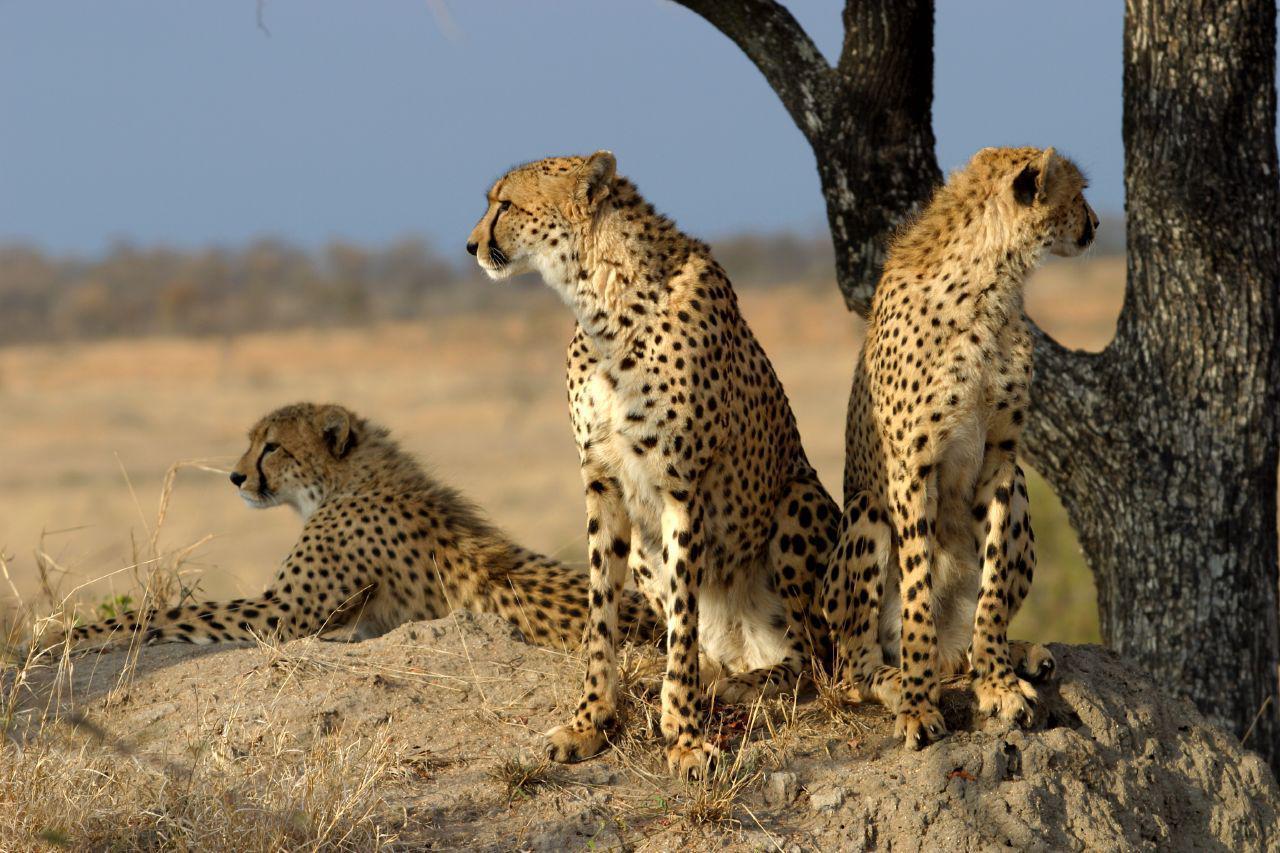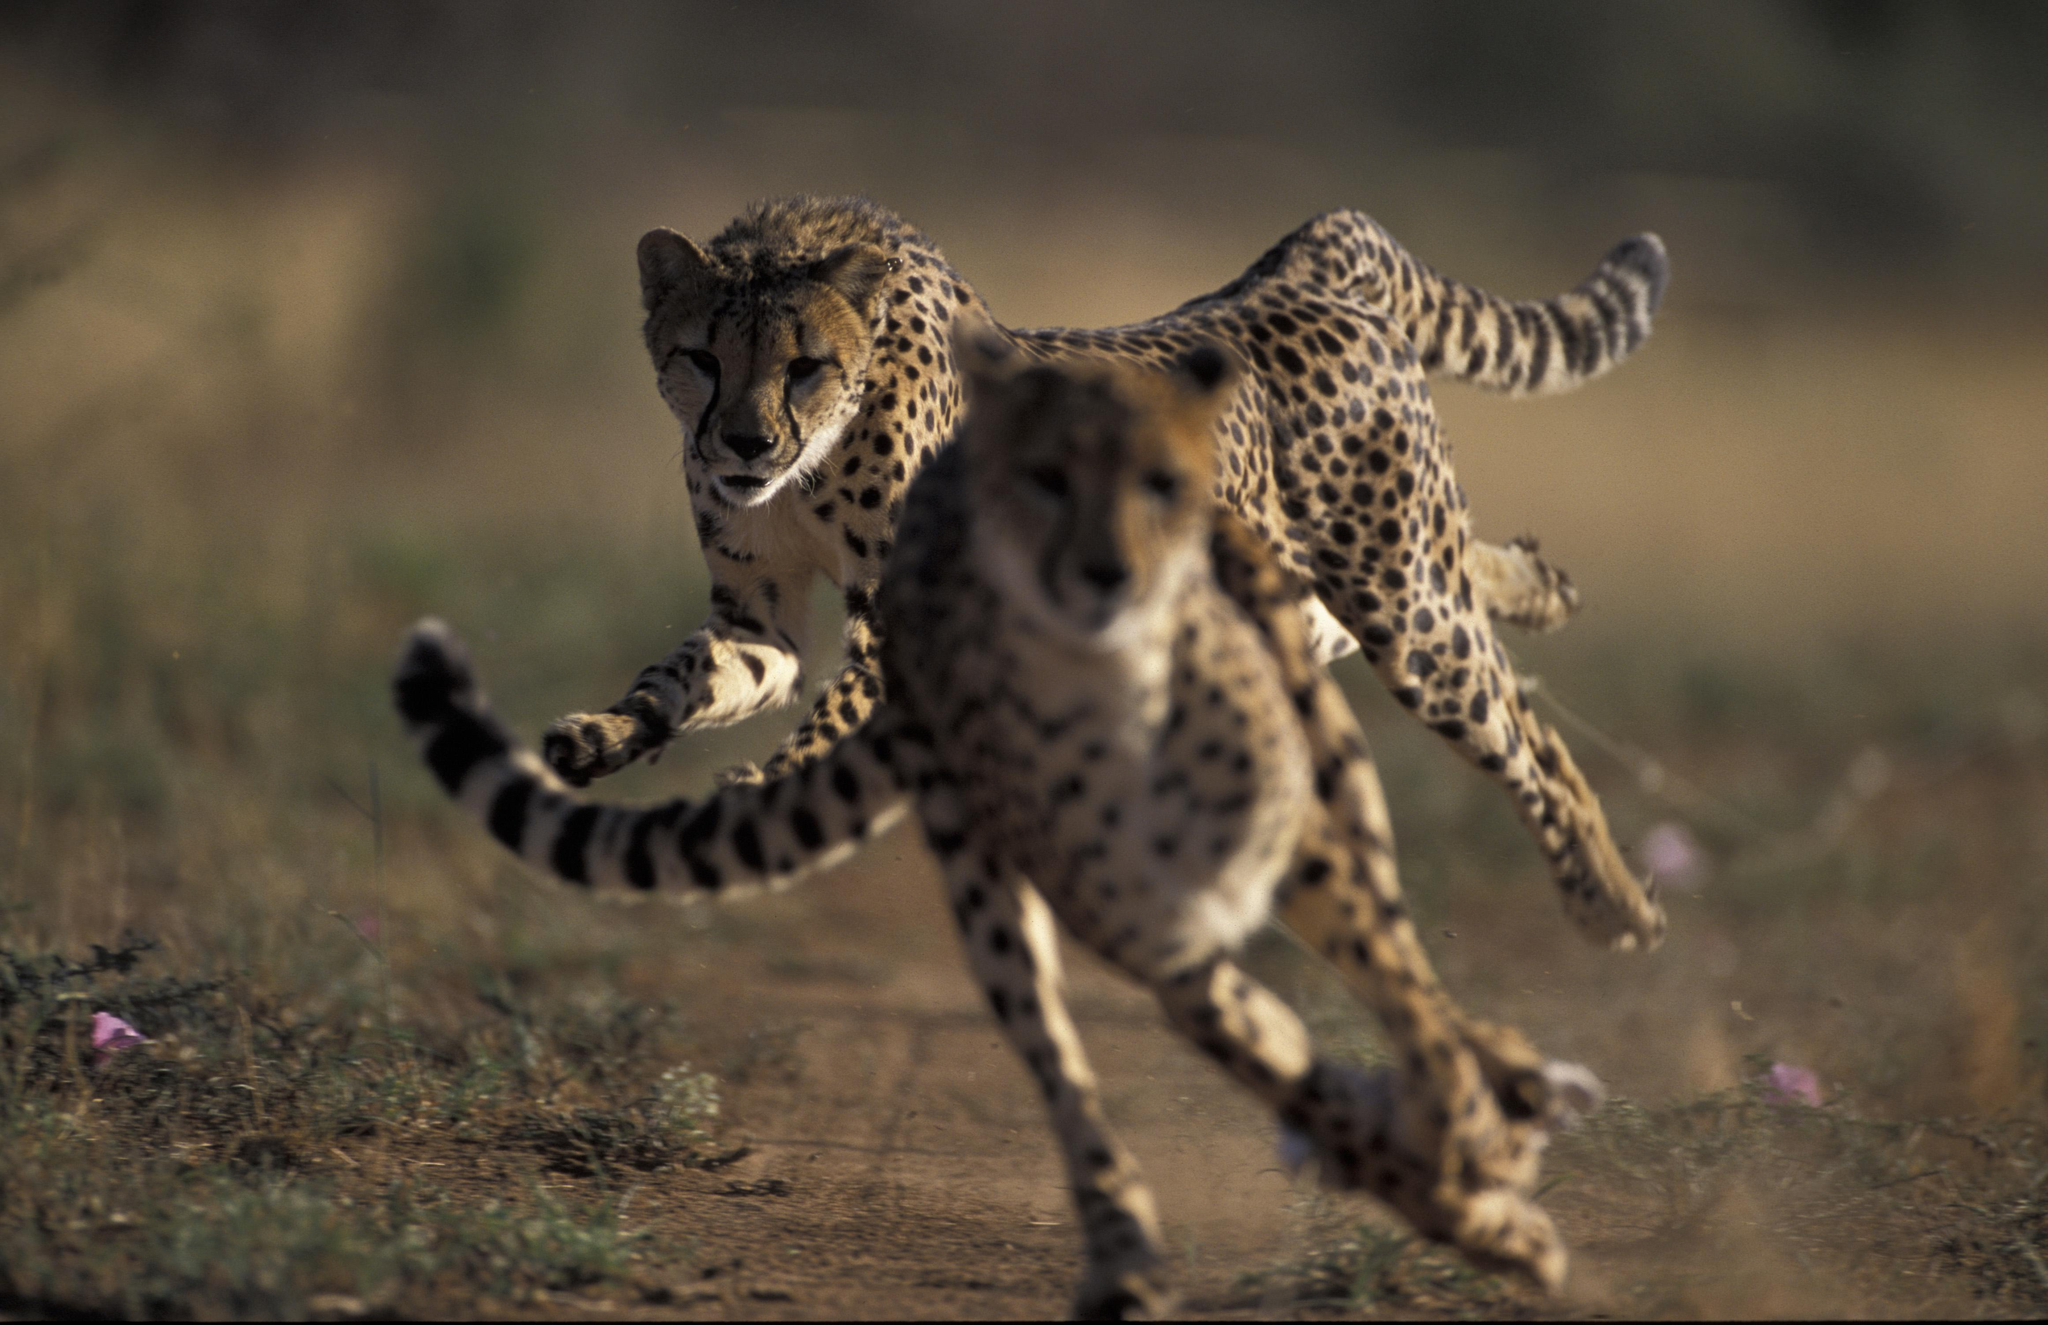The first image is the image on the left, the second image is the image on the right. For the images shown, is this caption "One of the images shows exactly two leopards." true? Answer yes or no. Yes. 